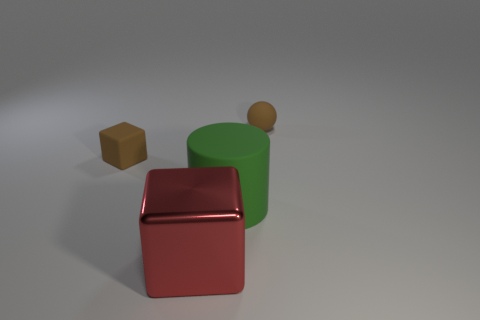There is a matte ball that is the same color as the small matte block; what size is it? small 